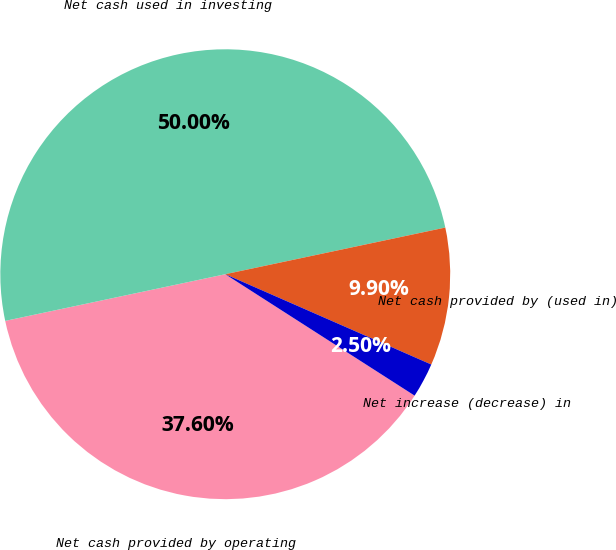<chart> <loc_0><loc_0><loc_500><loc_500><pie_chart><fcel>Net cash provided by operating<fcel>Net cash used in investing<fcel>Net cash provided by (used in)<fcel>Net increase (decrease) in<nl><fcel>37.6%<fcel>50.0%<fcel>9.9%<fcel>2.5%<nl></chart> 